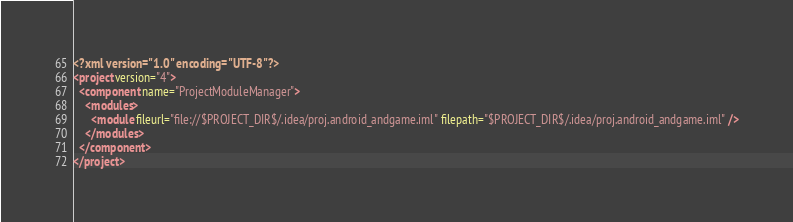<code> <loc_0><loc_0><loc_500><loc_500><_XML_><?xml version="1.0" encoding="UTF-8"?>
<project version="4">
  <component name="ProjectModuleManager">
    <modules>
      <module fileurl="file://$PROJECT_DIR$/.idea/proj.android_andgame.iml" filepath="$PROJECT_DIR$/.idea/proj.android_andgame.iml" />
    </modules>
  </component>
</project>

</code> 